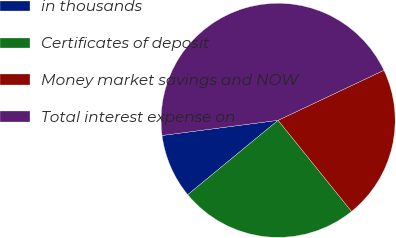Convert chart to OTSL. <chart><loc_0><loc_0><loc_500><loc_500><pie_chart><fcel>in thousands<fcel>Certificates of deposit<fcel>Money market savings and NOW<fcel>Total interest expense on<nl><fcel>8.89%<fcel>24.84%<fcel>21.23%<fcel>45.04%<nl></chart> 